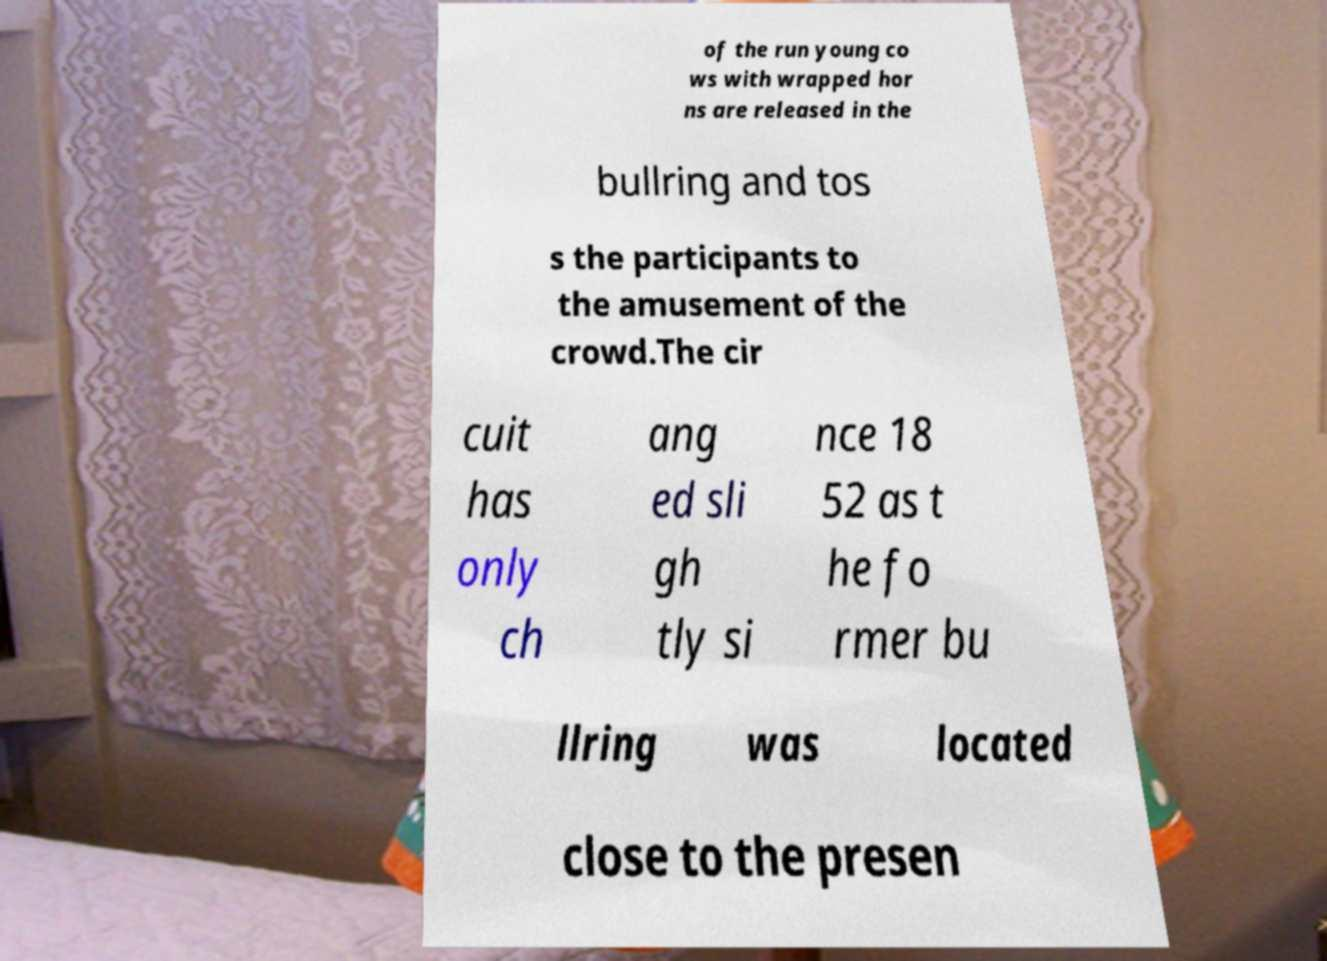I need the written content from this picture converted into text. Can you do that? of the run young co ws with wrapped hor ns are released in the bullring and tos s the participants to the amusement of the crowd.The cir cuit has only ch ang ed sli gh tly si nce 18 52 as t he fo rmer bu llring was located close to the presen 